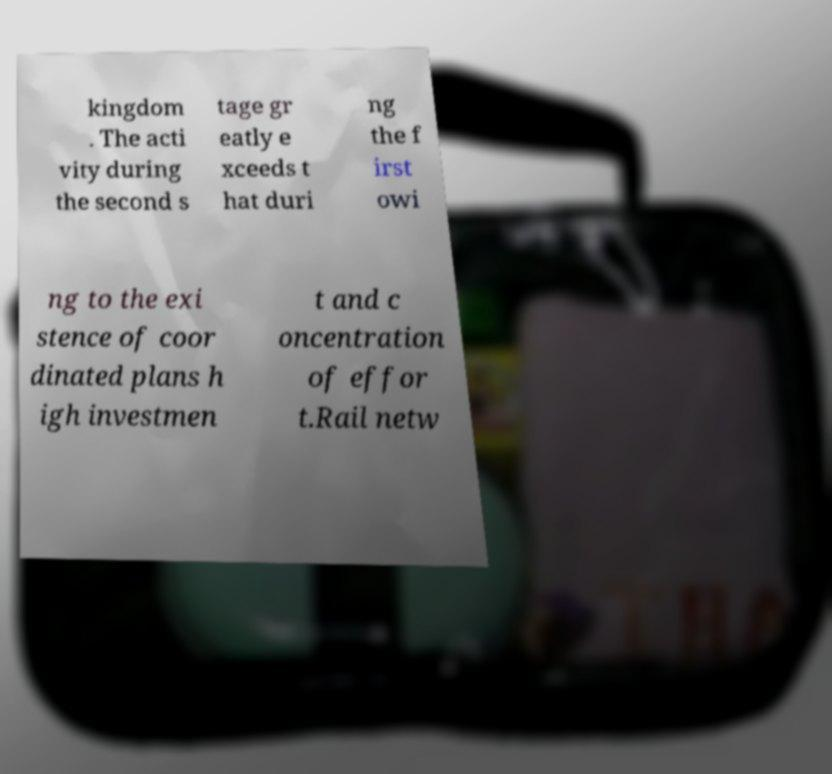Could you assist in decoding the text presented in this image and type it out clearly? kingdom . The acti vity during the second s tage gr eatly e xceeds t hat duri ng the f irst owi ng to the exi stence of coor dinated plans h igh investmen t and c oncentration of effor t.Rail netw 